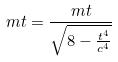<formula> <loc_0><loc_0><loc_500><loc_500>m t = \frac { m t } { \sqrt { 8 - \frac { t ^ { 4 } } { c ^ { 4 } } } }</formula> 